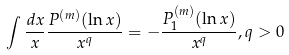<formula> <loc_0><loc_0><loc_500><loc_500>\int \frac { d x } { x } \frac { P ^ { ( m ) } ( \ln x ) } { x ^ { q } } = - \frac { P _ { 1 } ^ { ( m ) } ( \ln x ) } { x ^ { q } } , q > 0</formula> 